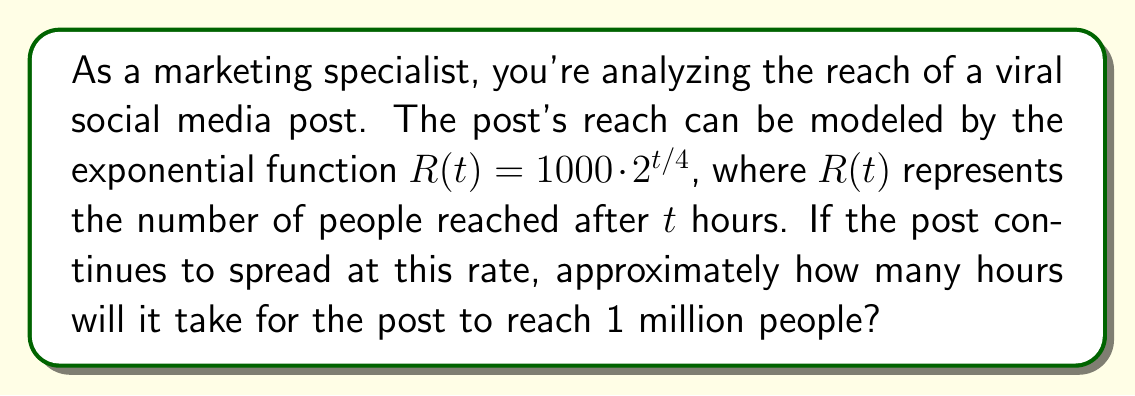Provide a solution to this math problem. To solve this problem, we need to use the given exponential function and solve for $t$ when $R(t) = 1,000,000$. Let's break it down step-by-step:

1) We start with the equation: $R(t) = 1000 \cdot 2^{t/4}$

2) We want to find $t$ when $R(t) = 1,000,000$, so we set up the equation:
   $1,000,000 = 1000 \cdot 2^{t/4}$

3) Divide both sides by 1000:
   $1,000 = 2^{t/4}$

4) Take the logarithm (base 2) of both sides:
   $\log_2(1,000) = \log_2(2^{t/4})$

5) Using the logarithm property $\log_a(a^x) = x$, we get:
   $\log_2(1,000) = t/4$

6) Multiply both sides by 4:
   $4 \log_2(1,000) = t$

7) Calculate $\log_2(1,000)$:
   $\log_2(1,000) \approx 9.97$

8) Therefore:
   $t \approx 4 \cdot 9.97 = 39.88$ hours

9) Rounding to the nearest hour, we get 40 hours.
Answer: It will take approximately 40 hours for the post to reach 1 million people. 